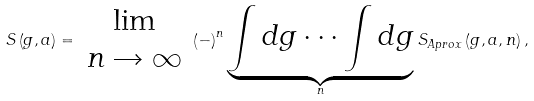<formula> <loc_0><loc_0><loc_500><loc_500>S \left ( g , a \right ) = \begin{array} { c } \lim \\ n \rightarrow \infty \end{array} \left ( - \right ) ^ { n } \underbrace { \int d g \cdots \int d g } _ { n } S _ { A p r o x } \left ( g , a , n \right ) ,</formula> 